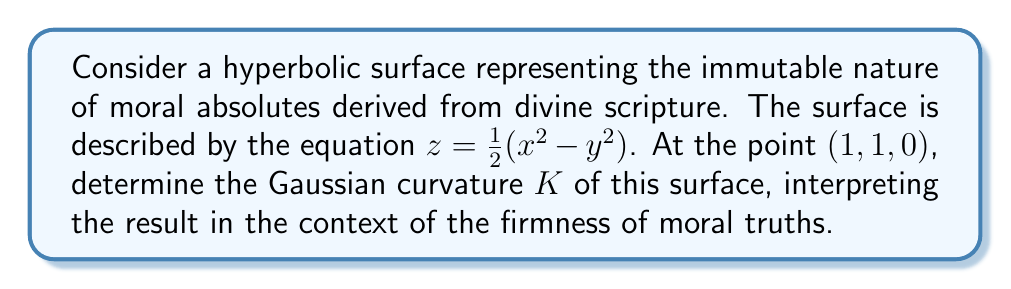Show me your answer to this math problem. To find the Gaussian curvature of the hyperbolic surface, we'll follow these steps:

1) The surface is given by $z = \frac{1}{2}(x^2 - y^2)$. We need to calculate the first and second fundamental forms.

2) First, let's compute the partial derivatives:
   $z_x = x$, $z_y = -y$, $z_{xx} = 1$, $z_{yy} = -1$, $z_{xy} = 0$

3) The components of the first fundamental form are:
   $E = 1 + z_x^2 = 1 + x^2$
   $F = z_x z_y = -xy$
   $G = 1 + z_y^2 = 1 + y^2$

4) The components of the second fundamental form are:
   $L = \frac{z_{xx}}{\sqrt{1 + z_x^2 + z_y^2}} = \frac{1}{\sqrt{1 + x^2 + y^2}}$
   $M = \frac{z_{xy}}{\sqrt{1 + z_x^2 + z_y^2}} = 0$
   $N = \frac{z_{yy}}{\sqrt{1 + z_x^2 + z_y^2}} = \frac{-1}{\sqrt{1 + x^2 + y^2}}$

5) The Gaussian curvature is given by:
   $K = \frac{LN - M^2}{EG - F^2}$

6) Substituting the values at the point $(1, 1, 0)$:
   $K = \frac{(\frac{1}{\sqrt{3}})(\frac{-1}{\sqrt{3}}) - 0^2}{(2)(2) - (-1)^2} = \frac{-\frac{1}{3}}{3} = -\frac{1}{9}$

7) Interpretation: The negative curvature (-1/9) at this point indicates that the surface is saddle-shaped, symbolizing the complex nature of moral absolutes. Despite their immutability, their application in real-world scenarios may require nuanced understanding, much like navigating a hyperbolic surface requires careful consideration of one's position and direction.
Answer: $K = -\frac{1}{9}$ 